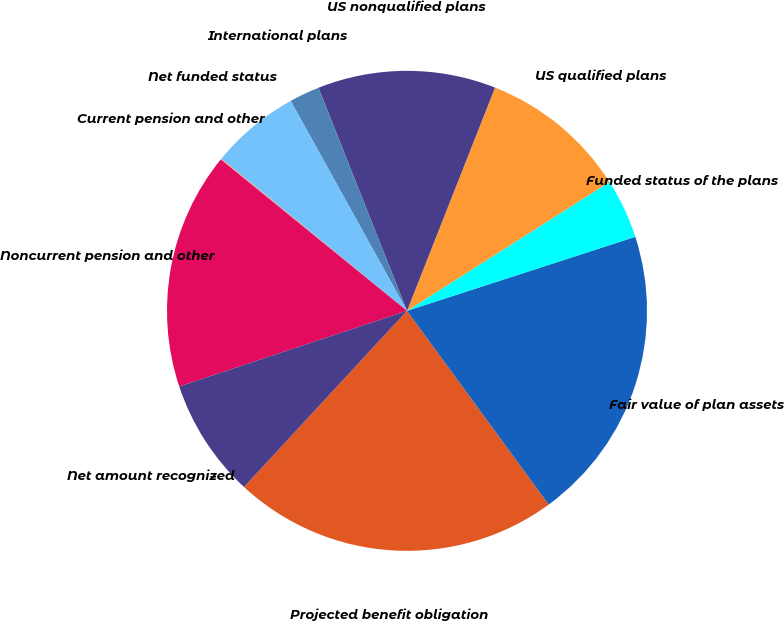<chart> <loc_0><loc_0><loc_500><loc_500><pie_chart><fcel>Projected benefit obligation<fcel>Fair value of plan assets<fcel>Funded status of the plans<fcel>US qualified plans<fcel>US nonqualified plans<fcel>International plans<fcel>Net funded status<fcel>Current pension and other<fcel>Noncurrent pension and other<fcel>Net amount recognized<nl><fcel>21.93%<fcel>19.94%<fcel>4.03%<fcel>10.0%<fcel>11.99%<fcel>2.04%<fcel>6.02%<fcel>0.06%<fcel>15.97%<fcel>8.01%<nl></chart> 